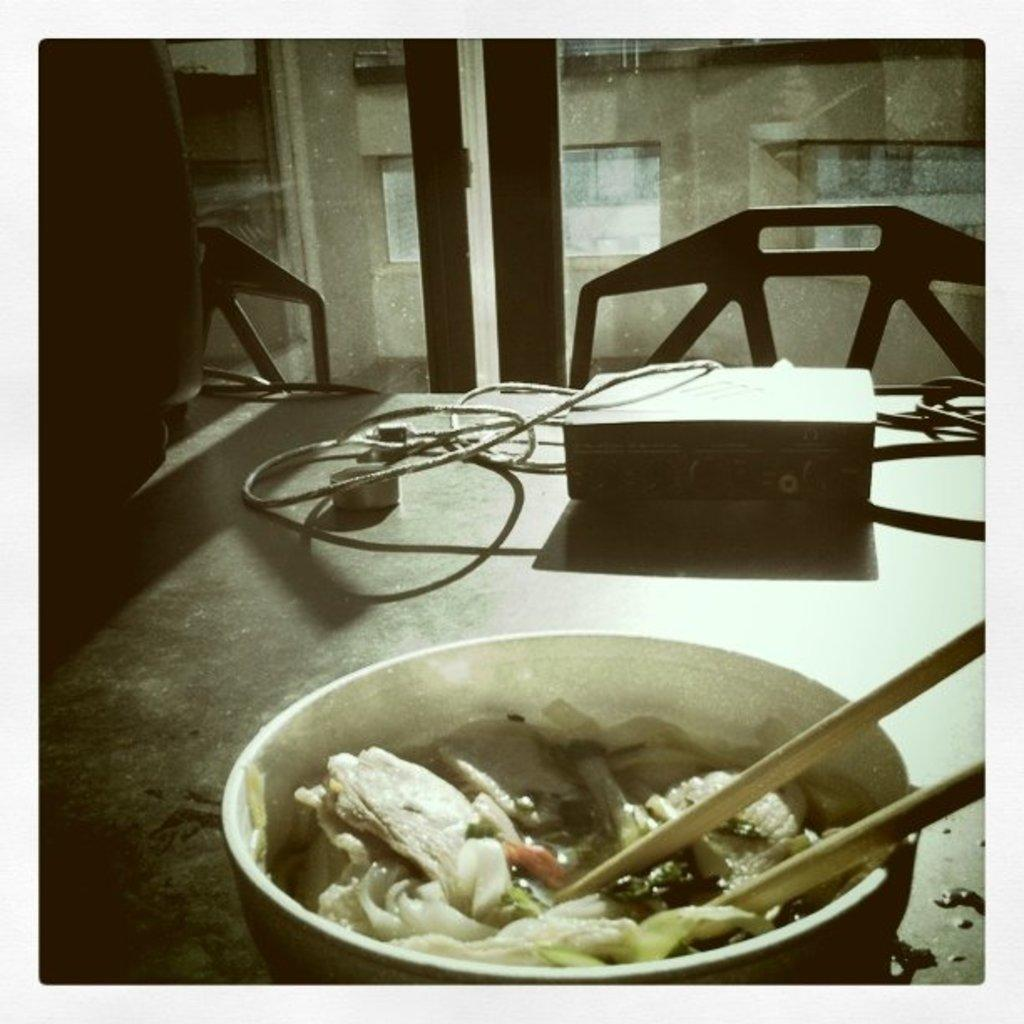What is the main piece of furniture in the image? There is a table in the image. What items can be seen on the table? There are wires, a box, a bowl, and chopsticks on the table. What is inside the bowl? There is food in the bowl. Can you describe the background of the image? There is a glass, a window, and a wall in the background of the image. How many cards are being held by the insect in the image? There are no insects or cards present in the image. What type of glove is being used to handle the food in the bowl? There are no gloves present in the image; the food is being handled with chopsticks. 